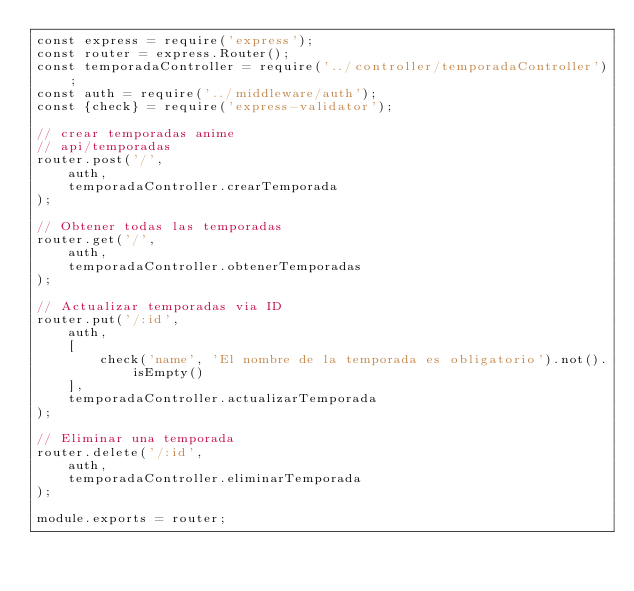Convert code to text. <code><loc_0><loc_0><loc_500><loc_500><_JavaScript_>const express = require('express');
const router = express.Router();
const temporadaController = require('../controller/temporadaController');
const auth = require('../middleware/auth');
const {check} = require('express-validator');

// crear temporadas anime
// api/temporadas
router.post('/',
    auth,
    temporadaController.crearTemporada
);

// Obtener todas las temporadas
router.get('/',
    auth,
    temporadaController.obtenerTemporadas
);

// Actualizar temporadas via ID
router.put('/:id',
    auth,
    [
        check('name', 'El nombre de la temporada es obligatorio').not().isEmpty()
    ],
    temporadaController.actualizarTemporada
);

// Eliminar una temporada
router.delete('/:id',
    auth,
    temporadaController.eliminarTemporada
);

module.exports = router;</code> 